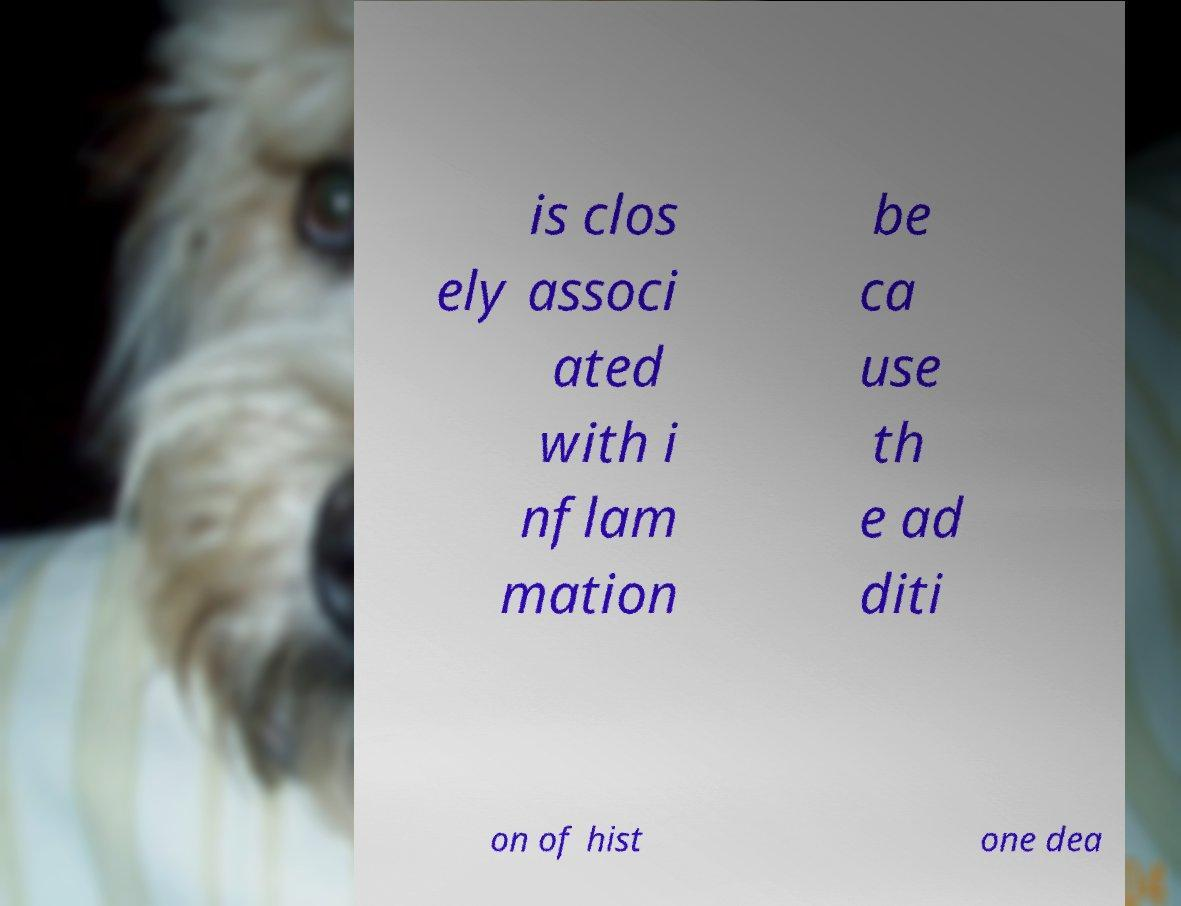Please identify and transcribe the text found in this image. is clos ely associ ated with i nflam mation be ca use th e ad diti on of hist one dea 